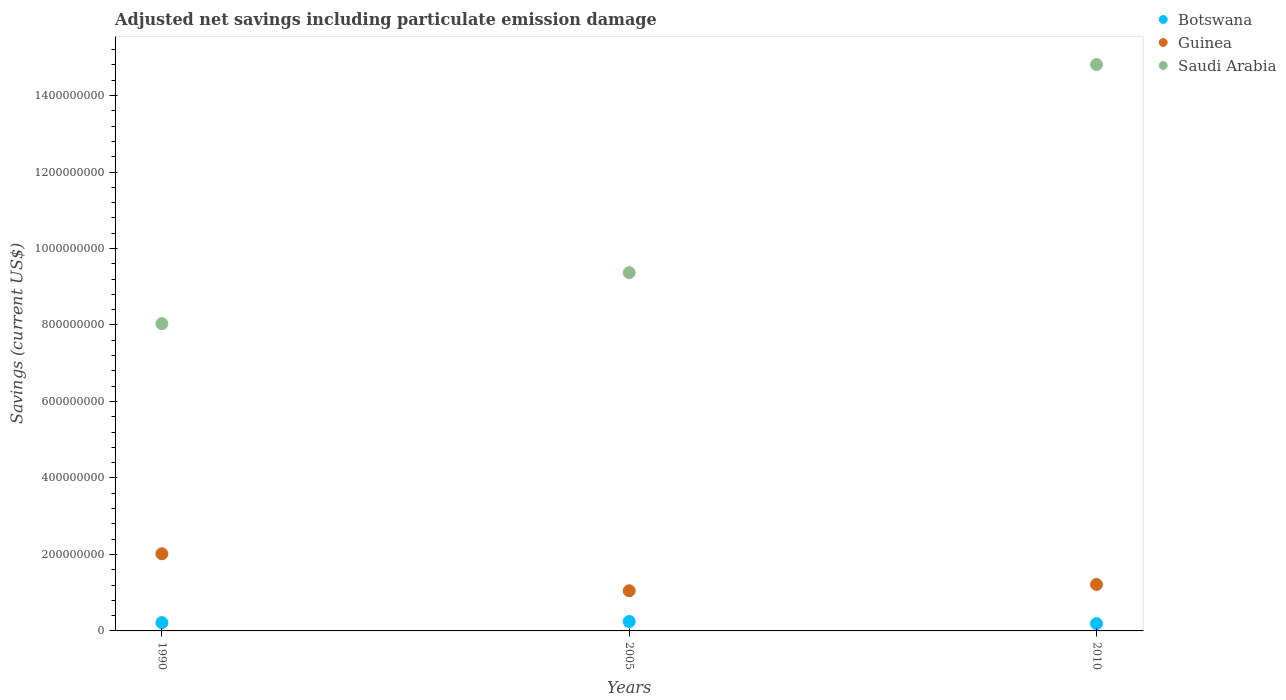How many different coloured dotlines are there?
Your response must be concise. 3. What is the net savings in Saudi Arabia in 1990?
Provide a succinct answer. 8.04e+08. Across all years, what is the maximum net savings in Botswana?
Provide a succinct answer. 2.46e+07. Across all years, what is the minimum net savings in Saudi Arabia?
Keep it short and to the point. 8.04e+08. In which year was the net savings in Guinea minimum?
Provide a succinct answer. 2005. What is the total net savings in Botswana in the graph?
Give a very brief answer. 6.54e+07. What is the difference between the net savings in Guinea in 1990 and that in 2005?
Ensure brevity in your answer.  9.67e+07. What is the difference between the net savings in Botswana in 2005 and the net savings in Guinea in 2010?
Give a very brief answer. -9.69e+07. What is the average net savings in Guinea per year?
Offer a terse response. 1.43e+08. In the year 2010, what is the difference between the net savings in Guinea and net savings in Botswana?
Offer a very short reply. 1.02e+08. What is the ratio of the net savings in Guinea in 1990 to that in 2010?
Offer a terse response. 1.66. Is the difference between the net savings in Guinea in 1990 and 2010 greater than the difference between the net savings in Botswana in 1990 and 2010?
Make the answer very short. Yes. What is the difference between the highest and the second highest net savings in Botswana?
Your answer should be compact. 2.91e+06. What is the difference between the highest and the lowest net savings in Guinea?
Provide a short and direct response. 9.67e+07. Is it the case that in every year, the sum of the net savings in Guinea and net savings in Saudi Arabia  is greater than the net savings in Botswana?
Ensure brevity in your answer.  Yes. Does the graph contain grids?
Your answer should be very brief. No. Where does the legend appear in the graph?
Offer a very short reply. Top right. How many legend labels are there?
Ensure brevity in your answer.  3. How are the legend labels stacked?
Offer a very short reply. Vertical. What is the title of the graph?
Keep it short and to the point. Adjusted net savings including particulate emission damage. What is the label or title of the Y-axis?
Your answer should be very brief. Savings (current US$). What is the Savings (current US$) of Botswana in 1990?
Your answer should be very brief. 2.17e+07. What is the Savings (current US$) of Guinea in 1990?
Make the answer very short. 2.02e+08. What is the Savings (current US$) of Saudi Arabia in 1990?
Your answer should be very brief. 8.04e+08. What is the Savings (current US$) of Botswana in 2005?
Provide a short and direct response. 2.46e+07. What is the Savings (current US$) of Guinea in 2005?
Give a very brief answer. 1.05e+08. What is the Savings (current US$) of Saudi Arabia in 2005?
Provide a short and direct response. 9.37e+08. What is the Savings (current US$) of Botswana in 2010?
Keep it short and to the point. 1.91e+07. What is the Savings (current US$) in Guinea in 2010?
Keep it short and to the point. 1.21e+08. What is the Savings (current US$) of Saudi Arabia in 2010?
Provide a short and direct response. 1.48e+09. Across all years, what is the maximum Savings (current US$) of Botswana?
Your answer should be very brief. 2.46e+07. Across all years, what is the maximum Savings (current US$) of Guinea?
Your answer should be very brief. 2.02e+08. Across all years, what is the maximum Savings (current US$) of Saudi Arabia?
Your answer should be compact. 1.48e+09. Across all years, what is the minimum Savings (current US$) in Botswana?
Keep it short and to the point. 1.91e+07. Across all years, what is the minimum Savings (current US$) of Guinea?
Give a very brief answer. 1.05e+08. Across all years, what is the minimum Savings (current US$) of Saudi Arabia?
Provide a short and direct response. 8.04e+08. What is the total Savings (current US$) in Botswana in the graph?
Your answer should be compact. 6.54e+07. What is the total Savings (current US$) in Guinea in the graph?
Ensure brevity in your answer.  4.28e+08. What is the total Savings (current US$) of Saudi Arabia in the graph?
Offer a terse response. 3.22e+09. What is the difference between the Savings (current US$) of Botswana in 1990 and that in 2005?
Provide a succinct answer. -2.91e+06. What is the difference between the Savings (current US$) of Guinea in 1990 and that in 2005?
Your response must be concise. 9.67e+07. What is the difference between the Savings (current US$) in Saudi Arabia in 1990 and that in 2005?
Ensure brevity in your answer.  -1.33e+08. What is the difference between the Savings (current US$) of Botswana in 1990 and that in 2010?
Your answer should be compact. 2.59e+06. What is the difference between the Savings (current US$) of Guinea in 1990 and that in 2010?
Your answer should be compact. 8.03e+07. What is the difference between the Savings (current US$) of Saudi Arabia in 1990 and that in 2010?
Ensure brevity in your answer.  -6.78e+08. What is the difference between the Savings (current US$) in Botswana in 2005 and that in 2010?
Ensure brevity in your answer.  5.50e+06. What is the difference between the Savings (current US$) in Guinea in 2005 and that in 2010?
Your answer should be very brief. -1.64e+07. What is the difference between the Savings (current US$) in Saudi Arabia in 2005 and that in 2010?
Ensure brevity in your answer.  -5.44e+08. What is the difference between the Savings (current US$) in Botswana in 1990 and the Savings (current US$) in Guinea in 2005?
Offer a very short reply. -8.34e+07. What is the difference between the Savings (current US$) in Botswana in 1990 and the Savings (current US$) in Saudi Arabia in 2005?
Your answer should be compact. -9.15e+08. What is the difference between the Savings (current US$) of Guinea in 1990 and the Savings (current US$) of Saudi Arabia in 2005?
Provide a succinct answer. -7.35e+08. What is the difference between the Savings (current US$) in Botswana in 1990 and the Savings (current US$) in Guinea in 2010?
Provide a succinct answer. -9.98e+07. What is the difference between the Savings (current US$) of Botswana in 1990 and the Savings (current US$) of Saudi Arabia in 2010?
Ensure brevity in your answer.  -1.46e+09. What is the difference between the Savings (current US$) of Guinea in 1990 and the Savings (current US$) of Saudi Arabia in 2010?
Your answer should be compact. -1.28e+09. What is the difference between the Savings (current US$) in Botswana in 2005 and the Savings (current US$) in Guinea in 2010?
Make the answer very short. -9.69e+07. What is the difference between the Savings (current US$) of Botswana in 2005 and the Savings (current US$) of Saudi Arabia in 2010?
Offer a terse response. -1.46e+09. What is the difference between the Savings (current US$) in Guinea in 2005 and the Savings (current US$) in Saudi Arabia in 2010?
Keep it short and to the point. -1.38e+09. What is the average Savings (current US$) of Botswana per year?
Keep it short and to the point. 2.18e+07. What is the average Savings (current US$) of Guinea per year?
Your response must be concise. 1.43e+08. What is the average Savings (current US$) of Saudi Arabia per year?
Give a very brief answer. 1.07e+09. In the year 1990, what is the difference between the Savings (current US$) of Botswana and Savings (current US$) of Guinea?
Keep it short and to the point. -1.80e+08. In the year 1990, what is the difference between the Savings (current US$) in Botswana and Savings (current US$) in Saudi Arabia?
Your response must be concise. -7.82e+08. In the year 1990, what is the difference between the Savings (current US$) of Guinea and Savings (current US$) of Saudi Arabia?
Keep it short and to the point. -6.02e+08. In the year 2005, what is the difference between the Savings (current US$) in Botswana and Savings (current US$) in Guinea?
Make the answer very short. -8.04e+07. In the year 2005, what is the difference between the Savings (current US$) of Botswana and Savings (current US$) of Saudi Arabia?
Offer a very short reply. -9.12e+08. In the year 2005, what is the difference between the Savings (current US$) of Guinea and Savings (current US$) of Saudi Arabia?
Offer a very short reply. -8.32e+08. In the year 2010, what is the difference between the Savings (current US$) in Botswana and Savings (current US$) in Guinea?
Ensure brevity in your answer.  -1.02e+08. In the year 2010, what is the difference between the Savings (current US$) of Botswana and Savings (current US$) of Saudi Arabia?
Offer a terse response. -1.46e+09. In the year 2010, what is the difference between the Savings (current US$) of Guinea and Savings (current US$) of Saudi Arabia?
Offer a terse response. -1.36e+09. What is the ratio of the Savings (current US$) in Botswana in 1990 to that in 2005?
Offer a terse response. 0.88. What is the ratio of the Savings (current US$) in Guinea in 1990 to that in 2005?
Make the answer very short. 1.92. What is the ratio of the Savings (current US$) of Saudi Arabia in 1990 to that in 2005?
Offer a terse response. 0.86. What is the ratio of the Savings (current US$) of Botswana in 1990 to that in 2010?
Offer a terse response. 1.14. What is the ratio of the Savings (current US$) of Guinea in 1990 to that in 2010?
Your answer should be very brief. 1.66. What is the ratio of the Savings (current US$) in Saudi Arabia in 1990 to that in 2010?
Provide a short and direct response. 0.54. What is the ratio of the Savings (current US$) of Botswana in 2005 to that in 2010?
Your response must be concise. 1.29. What is the ratio of the Savings (current US$) of Guinea in 2005 to that in 2010?
Your answer should be compact. 0.86. What is the ratio of the Savings (current US$) in Saudi Arabia in 2005 to that in 2010?
Ensure brevity in your answer.  0.63. What is the difference between the highest and the second highest Savings (current US$) of Botswana?
Provide a short and direct response. 2.91e+06. What is the difference between the highest and the second highest Savings (current US$) in Guinea?
Your answer should be very brief. 8.03e+07. What is the difference between the highest and the second highest Savings (current US$) of Saudi Arabia?
Your response must be concise. 5.44e+08. What is the difference between the highest and the lowest Savings (current US$) of Botswana?
Your answer should be compact. 5.50e+06. What is the difference between the highest and the lowest Savings (current US$) in Guinea?
Ensure brevity in your answer.  9.67e+07. What is the difference between the highest and the lowest Savings (current US$) in Saudi Arabia?
Provide a short and direct response. 6.78e+08. 